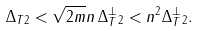<formula> <loc_0><loc_0><loc_500><loc_500>\| \Delta _ { T } \| _ { 2 } < \sqrt { 2 m } n \, \| \Delta _ { T } ^ { \bot } \| _ { 2 } < n ^ { 2 } \| \Delta _ { T } ^ { \bot } \| _ { 2 } .</formula> 